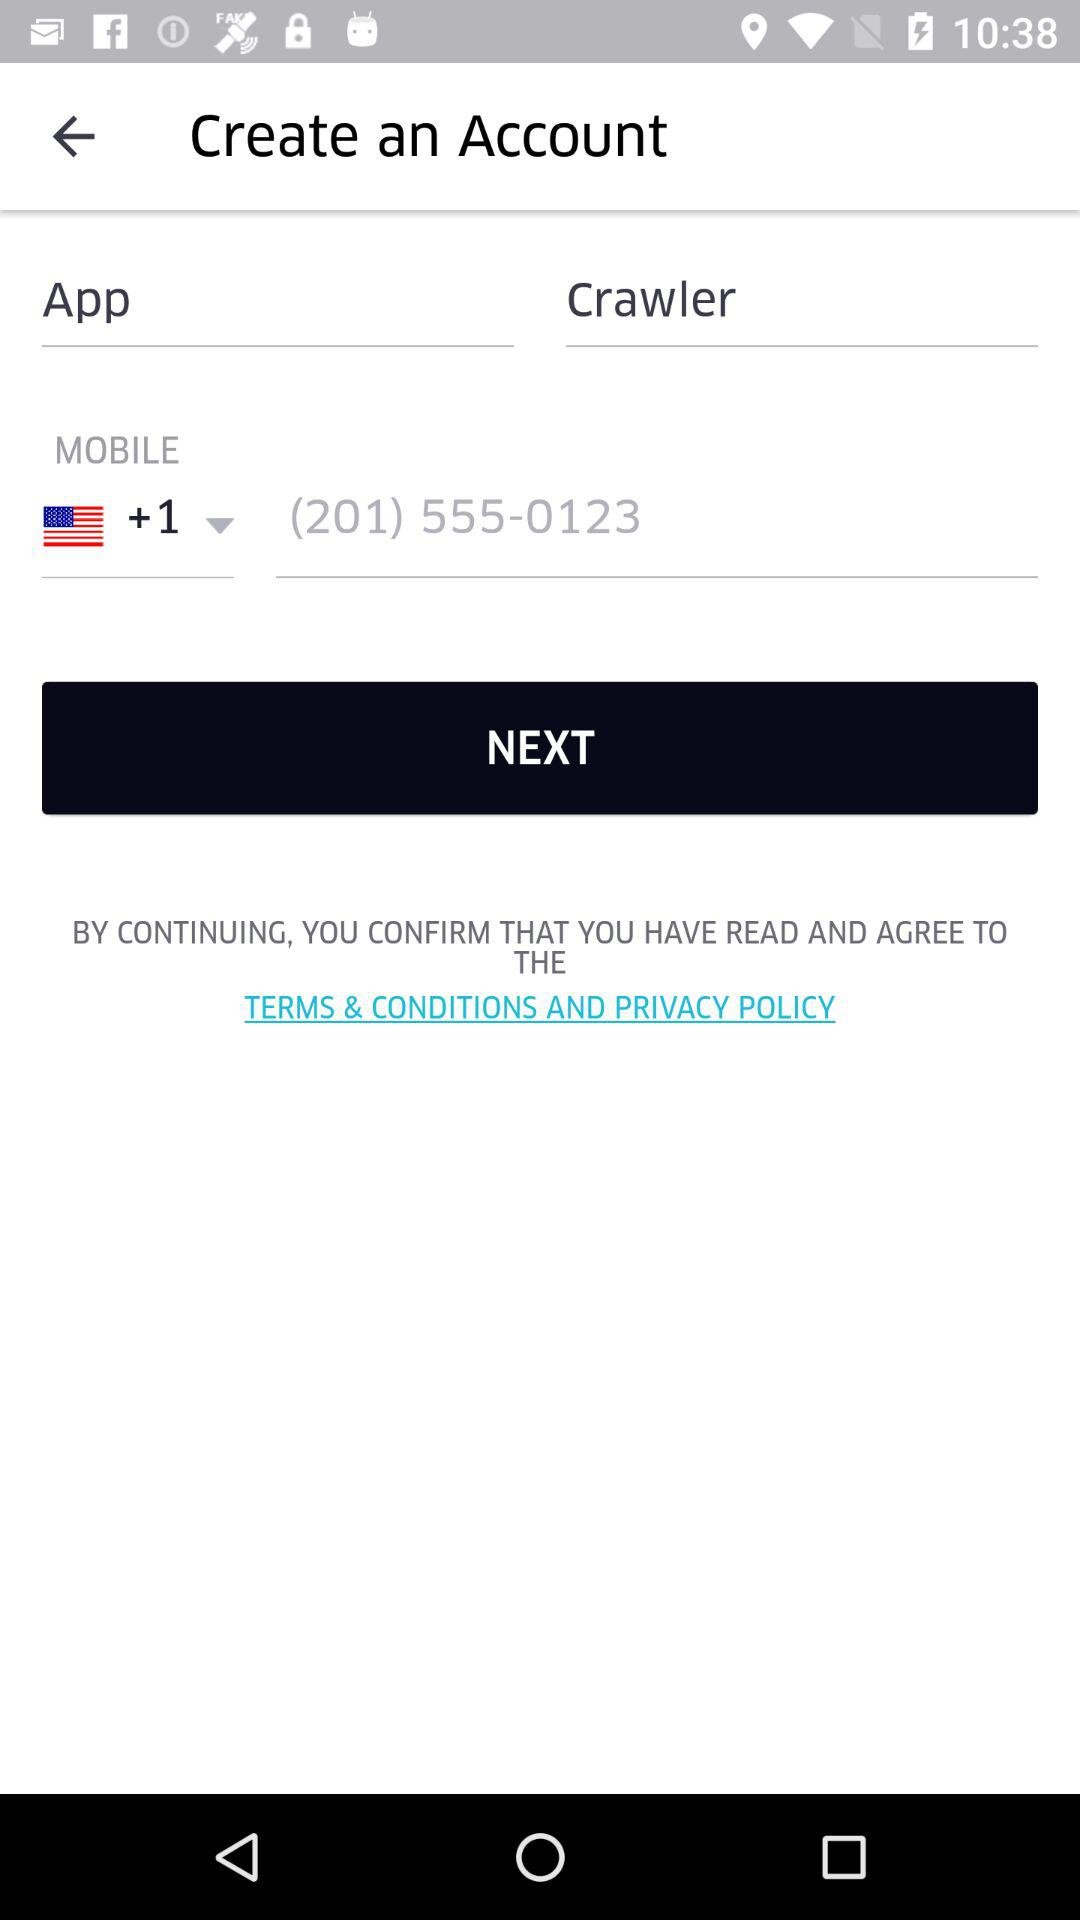What mobile number is given in the input field? The mobile number given in the input field is +1 201-555-0123. 